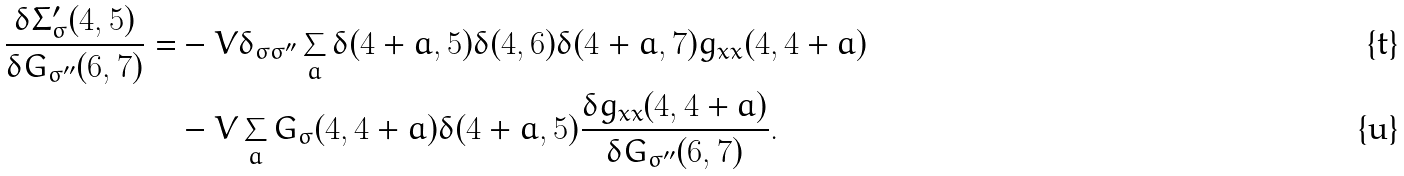<formula> <loc_0><loc_0><loc_500><loc_500>\frac { \delta \Sigma ^ { \prime } _ { \sigma } ( 4 , 5 ) } { \delta G _ { \sigma ^ { \prime \prime } } ( 6 , 7 ) } = & - V \delta _ { \sigma \sigma ^ { \prime \prime } } \sum _ { a } \delta ( 4 + a , 5 ) \delta ( 4 , 6 ) \delta ( 4 + a , 7 ) g _ { x x } ( 4 , 4 + a ) \\ & - V \sum _ { a } G _ { \sigma } ( 4 , 4 + a ) \delta ( 4 + a , 5 ) \frac { \delta g _ { x x } ( 4 , 4 + a ) } { \delta G _ { \sigma ^ { \prime \prime } } ( 6 , 7 ) } .</formula> 